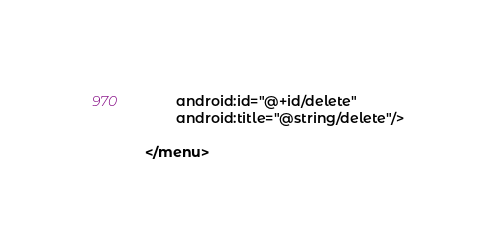Convert code to text. <code><loc_0><loc_0><loc_500><loc_500><_XML_>        android:id="@+id/delete"
        android:title="@string/delete"/>

</menu></code> 